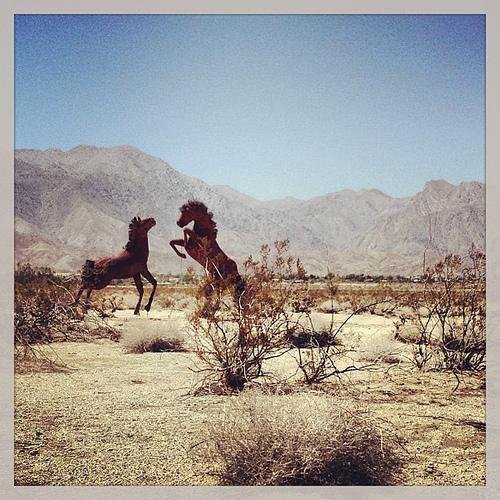How many horses are in the picture?
Give a very brief answer. 2. 